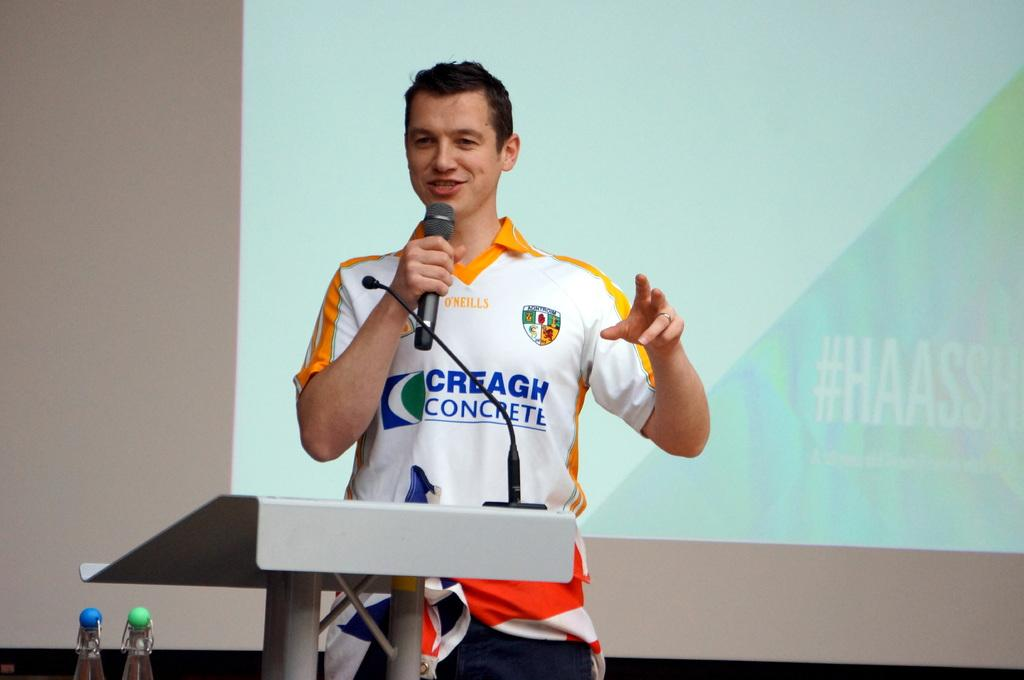Provide a one-sentence caption for the provided image. A young man in a Creagh Concrete shirt speaks into a microphone. 